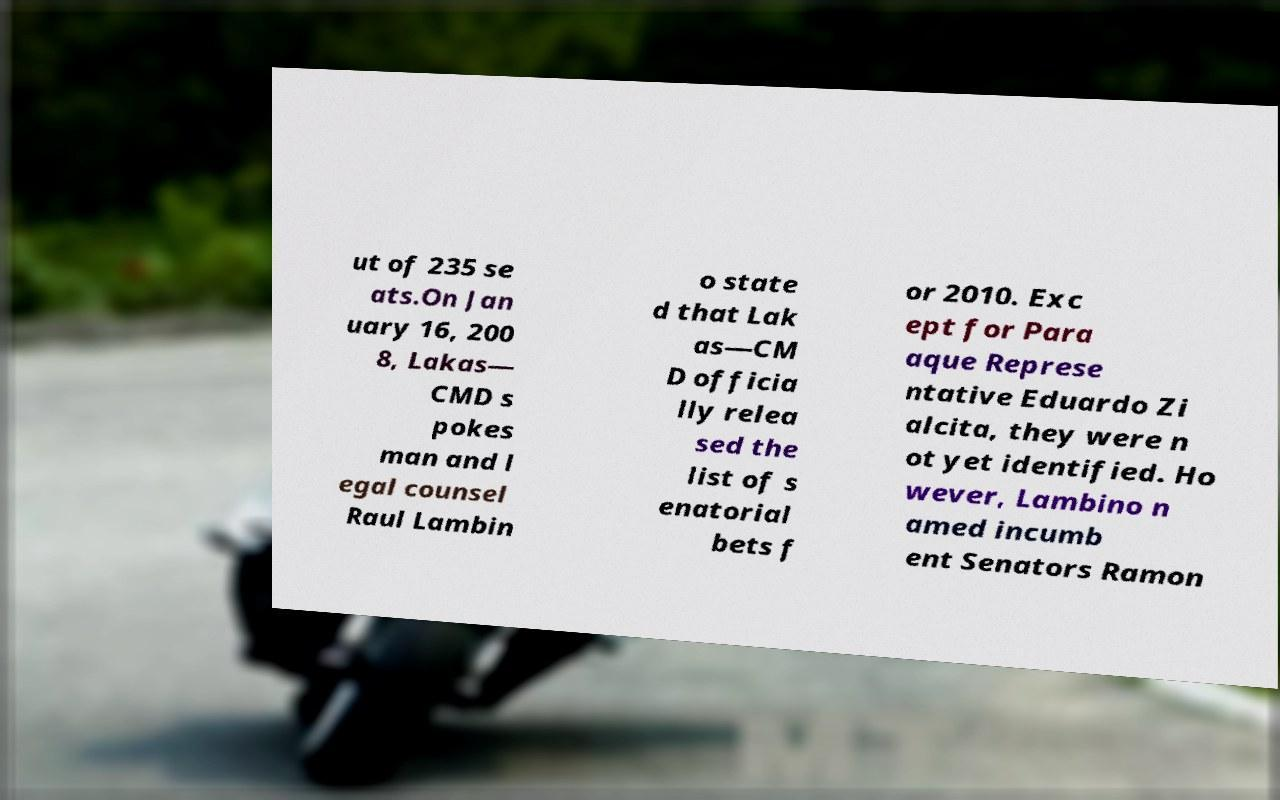For documentation purposes, I need the text within this image transcribed. Could you provide that? ut of 235 se ats.On Jan uary 16, 200 8, Lakas— CMD s pokes man and l egal counsel Raul Lambin o state d that Lak as—CM D officia lly relea sed the list of s enatorial bets f or 2010. Exc ept for Para aque Represe ntative Eduardo Zi alcita, they were n ot yet identified. Ho wever, Lambino n amed incumb ent Senators Ramon 